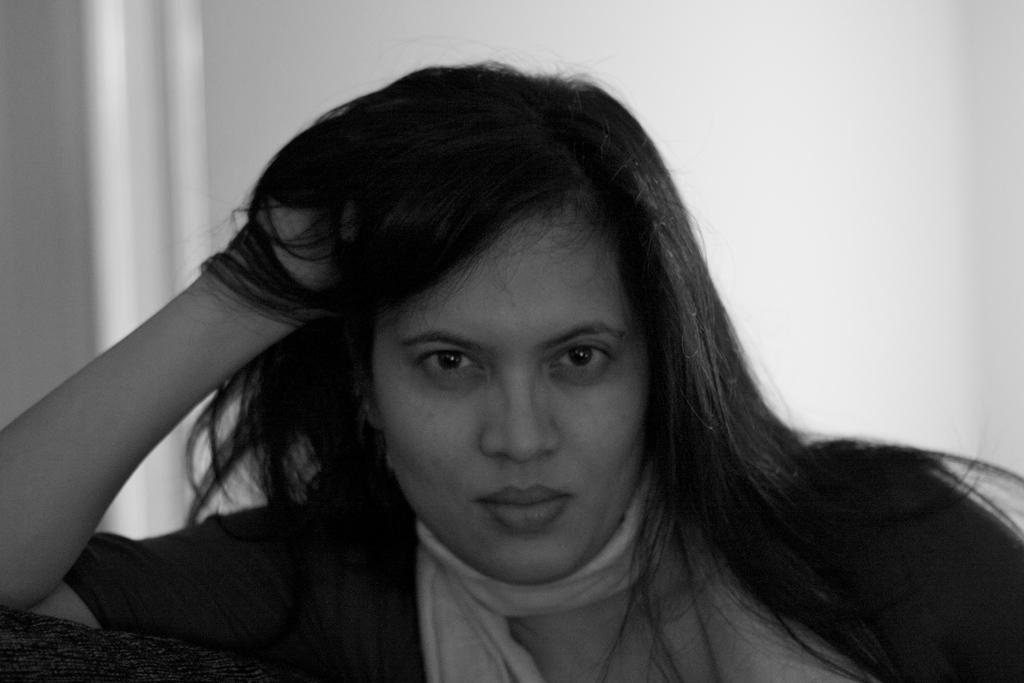What is the color scheme of the image? The image is black and white. Who or what is the main subject of the image? There is a woman in the image. What can be seen in the background of the image? The background of the image includes a wall. What type of music is being played in the background of the image? There is no music present in the image, as it is a black and white photograph of a woman in front of a wall. 